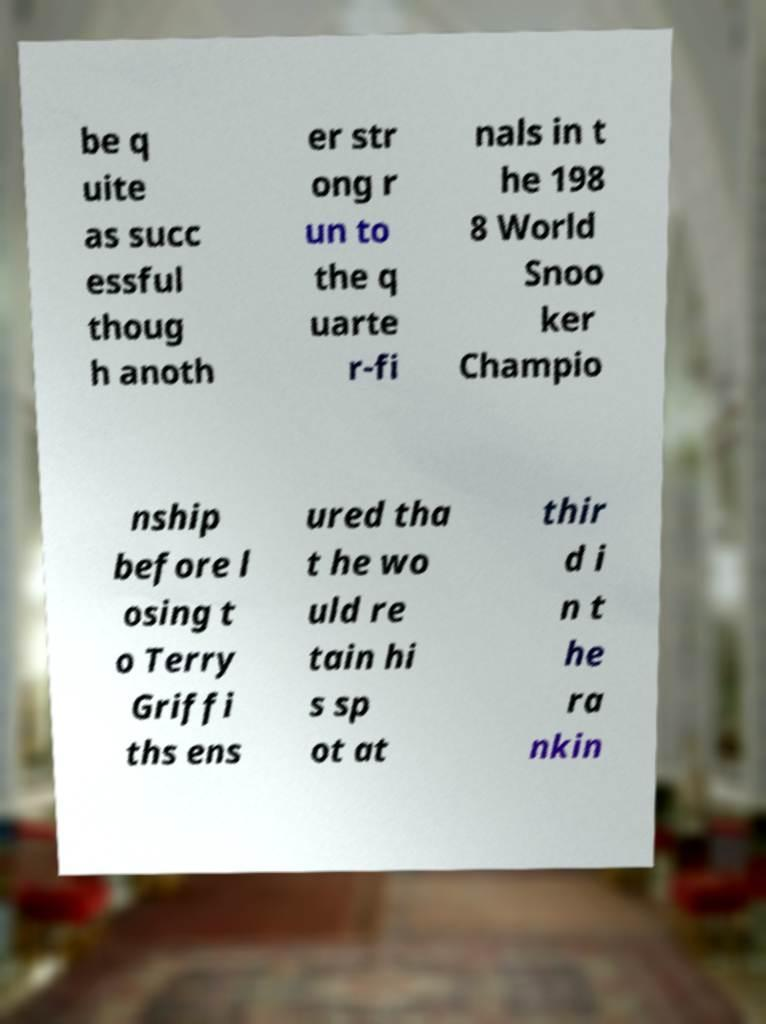Please read and relay the text visible in this image. What does it say? be q uite as succ essful thoug h anoth er str ong r un to the q uarte r-fi nals in t he 198 8 World Snoo ker Champio nship before l osing t o Terry Griffi ths ens ured tha t he wo uld re tain hi s sp ot at thir d i n t he ra nkin 